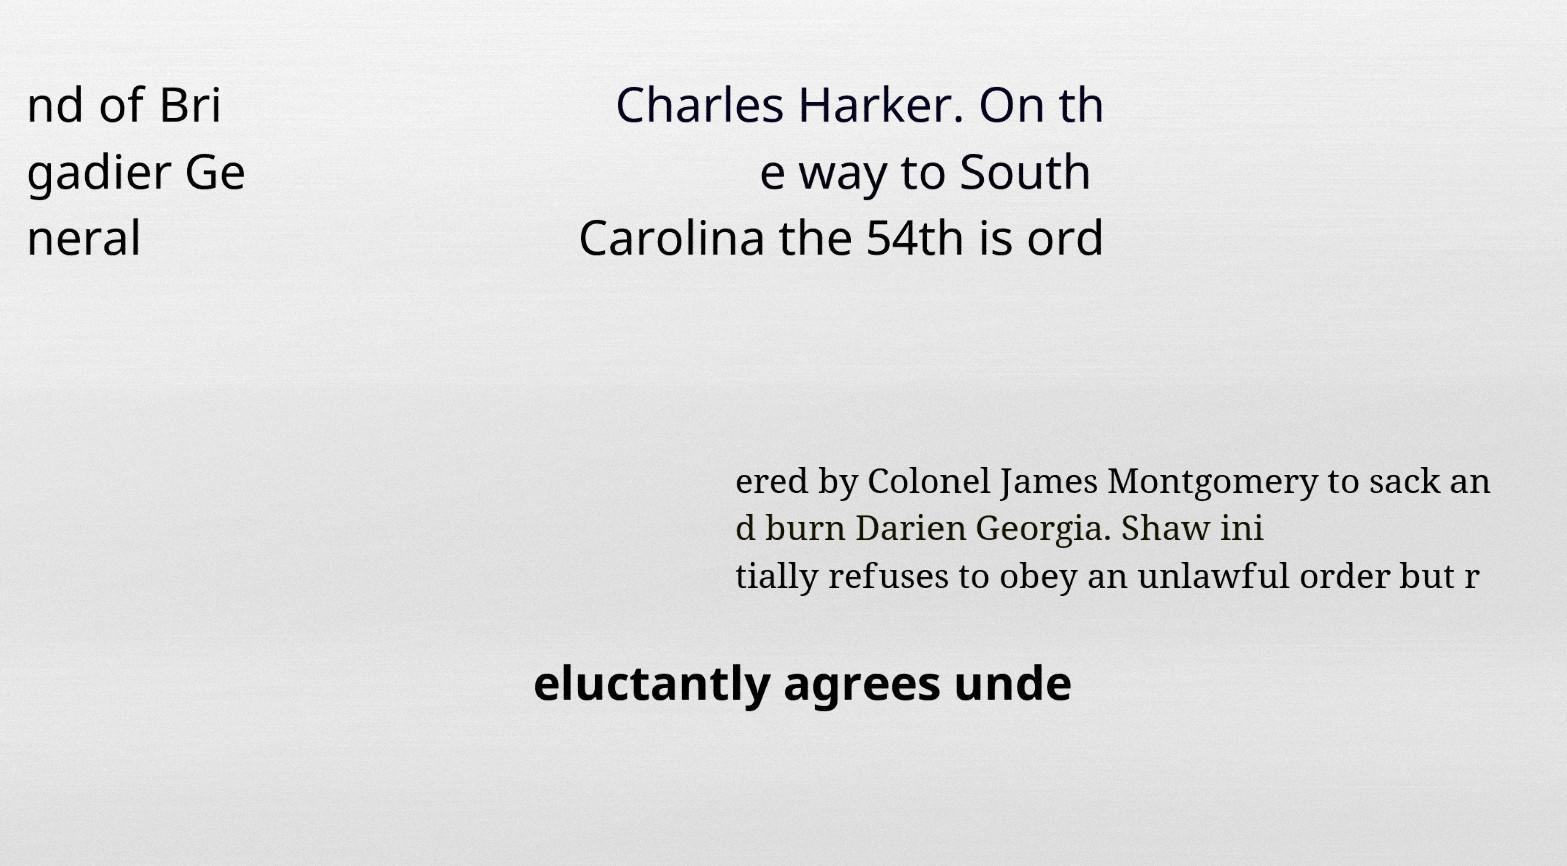There's text embedded in this image that I need extracted. Can you transcribe it verbatim? nd of Bri gadier Ge neral Charles Harker. On th e way to South Carolina the 54th is ord ered by Colonel James Montgomery to sack an d burn Darien Georgia. Shaw ini tially refuses to obey an unlawful order but r eluctantly agrees unde 